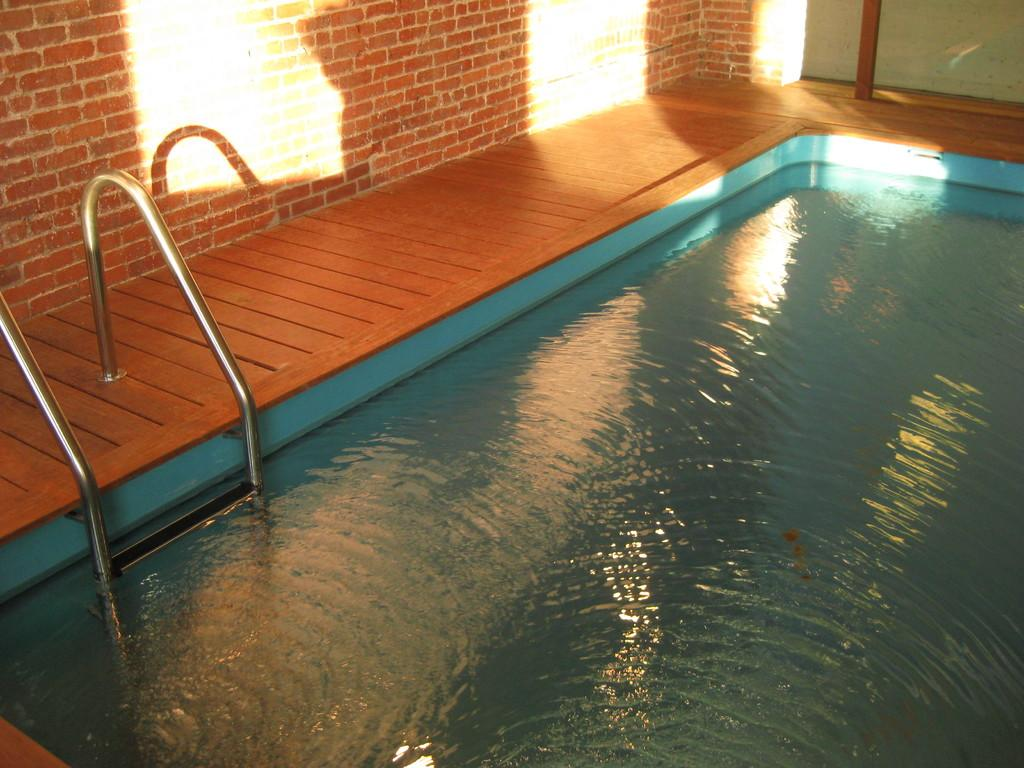What is the main feature in the image? There is a swimming pool in the image. What can be seen on the left side of the image? There is a wall on the left side of the image. What type of flooring is visible in the image? There is wooden flooring in the image. How many clouds are visible in the image? There are no clouds present in the image. 